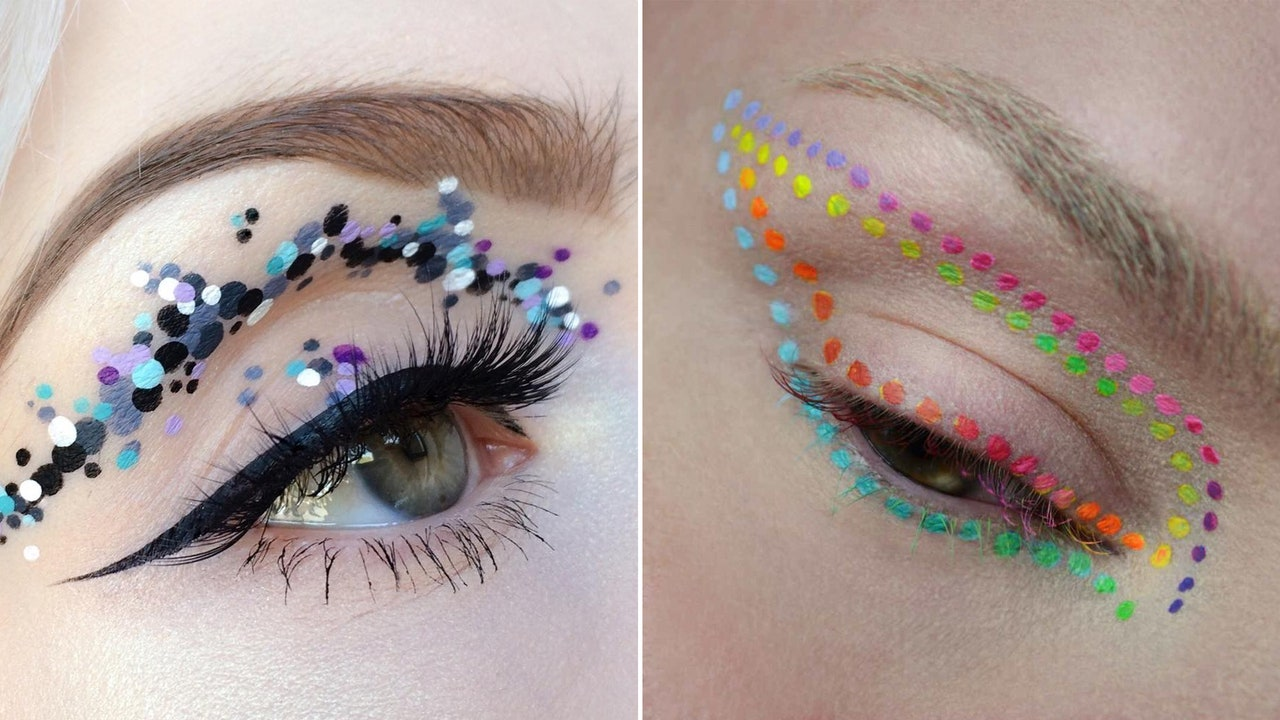What can be inferred about the possible context or event for which these makeup designs were created, considering the artistic and vibrant nature of the decorations? The intricate and colorful makeup designs suggest they could be intended for special occasions such as a fashion or beauty photoshoot, theatrical performances, or creative art exhibits. These makeup styles leverage vibrant colors and unconventional materials, including sequins and colored dots, pointing towards events that celebrate eccentric and artistic expression. Events like a costume gala, avant-garde art shows, or fashion week where such bold and expressive looks are encouraged, are likely venues for such makeup. 